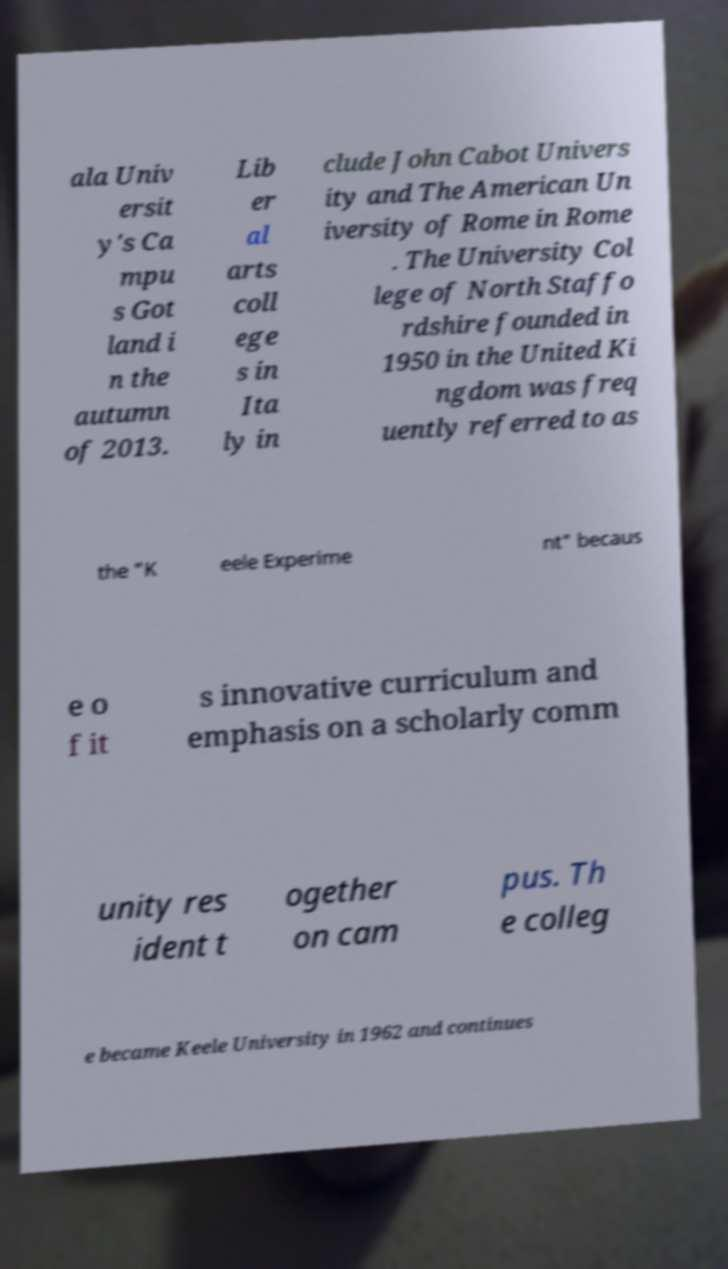Could you extract and type out the text from this image? ala Univ ersit y's Ca mpu s Got land i n the autumn of 2013. Lib er al arts coll ege s in Ita ly in clude John Cabot Univers ity and The American Un iversity of Rome in Rome . The University Col lege of North Staffo rdshire founded in 1950 in the United Ki ngdom was freq uently referred to as the "K eele Experime nt" becaus e o f it s innovative curriculum and emphasis on a scholarly comm unity res ident t ogether on cam pus. Th e colleg e became Keele University in 1962 and continues 